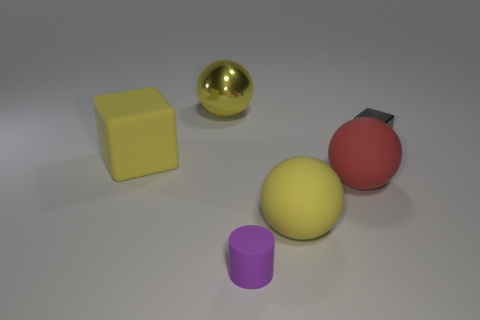What size is the rubber sphere that is the same color as the rubber cube?
Keep it short and to the point. Large. How many matte objects are small cyan objects or balls?
Your answer should be compact. 2. Are there any large yellow things behind the yellow matte thing that is left of the big sphere on the left side of the purple cylinder?
Your answer should be compact. Yes. There is a yellow matte ball; how many purple rubber objects are to the left of it?
Ensure brevity in your answer.  1. What is the material of the other large sphere that is the same color as the metallic sphere?
Make the answer very short. Rubber. How many large things are gray metallic things or purple rubber objects?
Your response must be concise. 0. What shape is the thing left of the yellow metallic object?
Make the answer very short. Cube. Is there a big cube of the same color as the large metallic sphere?
Your answer should be very brief. Yes. Does the cube right of the large red sphere have the same size as the sphere that is behind the red rubber thing?
Offer a terse response. No. Is the number of small gray cubes behind the tiny shiny cube greater than the number of big spheres behind the large red rubber ball?
Your answer should be compact. No. 